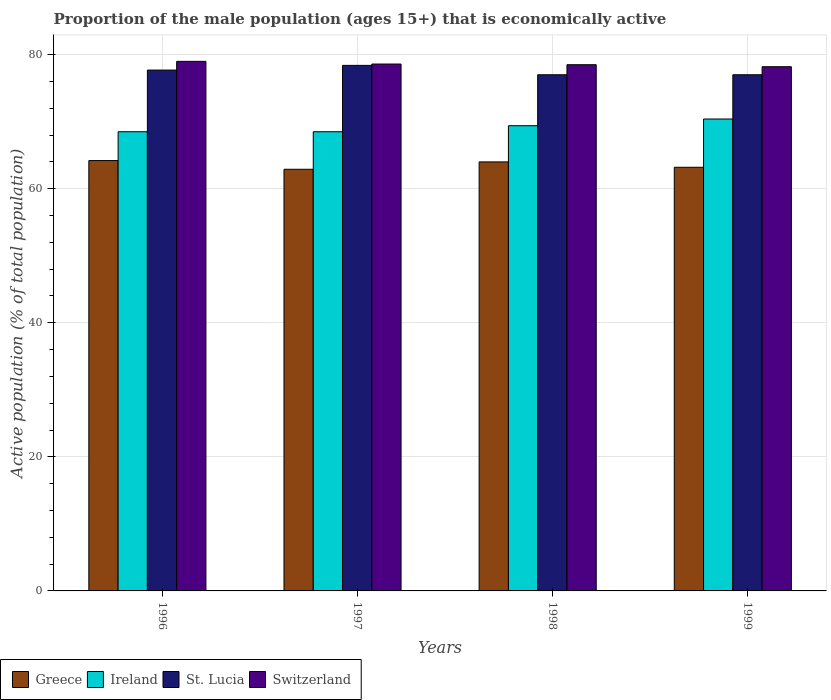How many different coloured bars are there?
Make the answer very short. 4. How many groups of bars are there?
Keep it short and to the point. 4. What is the label of the 1st group of bars from the left?
Your answer should be compact. 1996. In how many cases, is the number of bars for a given year not equal to the number of legend labels?
Offer a terse response. 0. What is the proportion of the male population that is economically active in Switzerland in 1997?
Your answer should be very brief. 78.6. Across all years, what is the maximum proportion of the male population that is economically active in Ireland?
Your answer should be compact. 70.4. Across all years, what is the minimum proportion of the male population that is economically active in Greece?
Ensure brevity in your answer.  62.9. In which year was the proportion of the male population that is economically active in Switzerland minimum?
Offer a very short reply. 1999. What is the total proportion of the male population that is economically active in Greece in the graph?
Offer a terse response. 254.3. What is the difference between the proportion of the male population that is economically active in Greece in 1996 and that in 1997?
Your response must be concise. 1.3. What is the difference between the proportion of the male population that is economically active in Greece in 1998 and the proportion of the male population that is economically active in Ireland in 1999?
Provide a short and direct response. -6.4. What is the average proportion of the male population that is economically active in Switzerland per year?
Your response must be concise. 78.57. In the year 1997, what is the difference between the proportion of the male population that is economically active in Switzerland and proportion of the male population that is economically active in Greece?
Offer a terse response. 15.7. In how many years, is the proportion of the male population that is economically active in Switzerland greater than 64 %?
Your answer should be compact. 4. What is the ratio of the proportion of the male population that is economically active in Greece in 1996 to that in 1998?
Ensure brevity in your answer.  1. Is the proportion of the male population that is economically active in St. Lucia in 1996 less than that in 1999?
Provide a short and direct response. No. Is the difference between the proportion of the male population that is economically active in Switzerland in 1996 and 1999 greater than the difference between the proportion of the male population that is economically active in Greece in 1996 and 1999?
Provide a short and direct response. No. What is the difference between the highest and the second highest proportion of the male population that is economically active in St. Lucia?
Ensure brevity in your answer.  0.7. What is the difference between the highest and the lowest proportion of the male population that is economically active in Greece?
Your answer should be compact. 1.3. What does the 2nd bar from the left in 1999 represents?
Provide a succinct answer. Ireland. What does the 4th bar from the right in 1998 represents?
Make the answer very short. Greece. Does the graph contain grids?
Your answer should be compact. Yes. How are the legend labels stacked?
Your answer should be compact. Horizontal. What is the title of the graph?
Make the answer very short. Proportion of the male population (ages 15+) that is economically active. What is the label or title of the X-axis?
Keep it short and to the point. Years. What is the label or title of the Y-axis?
Ensure brevity in your answer.  Active population (% of total population). What is the Active population (% of total population) of Greece in 1996?
Offer a very short reply. 64.2. What is the Active population (% of total population) in Ireland in 1996?
Provide a succinct answer. 68.5. What is the Active population (% of total population) of St. Lucia in 1996?
Provide a short and direct response. 77.7. What is the Active population (% of total population) in Switzerland in 1996?
Ensure brevity in your answer.  79. What is the Active population (% of total population) in Greece in 1997?
Offer a terse response. 62.9. What is the Active population (% of total population) in Ireland in 1997?
Your answer should be compact. 68.5. What is the Active population (% of total population) in St. Lucia in 1997?
Offer a terse response. 78.4. What is the Active population (% of total population) in Switzerland in 1997?
Your answer should be very brief. 78.6. What is the Active population (% of total population) in Ireland in 1998?
Provide a succinct answer. 69.4. What is the Active population (% of total population) of Switzerland in 1998?
Offer a terse response. 78.5. What is the Active population (% of total population) in Greece in 1999?
Offer a terse response. 63.2. What is the Active population (% of total population) of Ireland in 1999?
Make the answer very short. 70.4. What is the Active population (% of total population) in St. Lucia in 1999?
Give a very brief answer. 77. What is the Active population (% of total population) in Switzerland in 1999?
Provide a succinct answer. 78.2. Across all years, what is the maximum Active population (% of total population) in Greece?
Make the answer very short. 64.2. Across all years, what is the maximum Active population (% of total population) in Ireland?
Offer a terse response. 70.4. Across all years, what is the maximum Active population (% of total population) in St. Lucia?
Offer a very short reply. 78.4. Across all years, what is the maximum Active population (% of total population) of Switzerland?
Keep it short and to the point. 79. Across all years, what is the minimum Active population (% of total population) in Greece?
Keep it short and to the point. 62.9. Across all years, what is the minimum Active population (% of total population) in Ireland?
Your response must be concise. 68.5. Across all years, what is the minimum Active population (% of total population) in Switzerland?
Keep it short and to the point. 78.2. What is the total Active population (% of total population) of Greece in the graph?
Offer a very short reply. 254.3. What is the total Active population (% of total population) in Ireland in the graph?
Your response must be concise. 276.8. What is the total Active population (% of total population) in St. Lucia in the graph?
Make the answer very short. 310.1. What is the total Active population (% of total population) of Switzerland in the graph?
Provide a succinct answer. 314.3. What is the difference between the Active population (% of total population) of Ireland in 1996 and that in 1997?
Ensure brevity in your answer.  0. What is the difference between the Active population (% of total population) of St. Lucia in 1996 and that in 1997?
Offer a very short reply. -0.7. What is the difference between the Active population (% of total population) of Switzerland in 1996 and that in 1997?
Offer a terse response. 0.4. What is the difference between the Active population (% of total population) in Ireland in 1996 and that in 1998?
Offer a terse response. -0.9. What is the difference between the Active population (% of total population) in Ireland in 1996 and that in 1999?
Your answer should be very brief. -1.9. What is the difference between the Active population (% of total population) in Switzerland in 1996 and that in 1999?
Offer a terse response. 0.8. What is the difference between the Active population (% of total population) in Greece in 1997 and that in 1998?
Offer a terse response. -1.1. What is the difference between the Active population (% of total population) in Switzerland in 1997 and that in 1998?
Ensure brevity in your answer.  0.1. What is the difference between the Active population (% of total population) of St. Lucia in 1997 and that in 1999?
Provide a short and direct response. 1.4. What is the difference between the Active population (% of total population) in Switzerland in 1997 and that in 1999?
Provide a short and direct response. 0.4. What is the difference between the Active population (% of total population) in Greece in 1998 and that in 1999?
Give a very brief answer. 0.8. What is the difference between the Active population (% of total population) in Ireland in 1998 and that in 1999?
Make the answer very short. -1. What is the difference between the Active population (% of total population) in St. Lucia in 1998 and that in 1999?
Offer a terse response. 0. What is the difference between the Active population (% of total population) of Greece in 1996 and the Active population (% of total population) of Ireland in 1997?
Ensure brevity in your answer.  -4.3. What is the difference between the Active population (% of total population) of Greece in 1996 and the Active population (% of total population) of St. Lucia in 1997?
Offer a terse response. -14.2. What is the difference between the Active population (% of total population) in Greece in 1996 and the Active population (% of total population) in Switzerland in 1997?
Make the answer very short. -14.4. What is the difference between the Active population (% of total population) in Ireland in 1996 and the Active population (% of total population) in Switzerland in 1997?
Offer a terse response. -10.1. What is the difference between the Active population (% of total population) in St. Lucia in 1996 and the Active population (% of total population) in Switzerland in 1997?
Provide a succinct answer. -0.9. What is the difference between the Active population (% of total population) of Greece in 1996 and the Active population (% of total population) of Switzerland in 1998?
Offer a terse response. -14.3. What is the difference between the Active population (% of total population) of Ireland in 1996 and the Active population (% of total population) of St. Lucia in 1998?
Give a very brief answer. -8.5. What is the difference between the Active population (% of total population) of Ireland in 1996 and the Active population (% of total population) of Switzerland in 1998?
Ensure brevity in your answer.  -10. What is the difference between the Active population (% of total population) in Greece in 1996 and the Active population (% of total population) in Ireland in 1999?
Your answer should be very brief. -6.2. What is the difference between the Active population (% of total population) in Ireland in 1996 and the Active population (% of total population) in Switzerland in 1999?
Ensure brevity in your answer.  -9.7. What is the difference between the Active population (% of total population) in Greece in 1997 and the Active population (% of total population) in Ireland in 1998?
Your answer should be very brief. -6.5. What is the difference between the Active population (% of total population) of Greece in 1997 and the Active population (% of total population) of St. Lucia in 1998?
Offer a terse response. -14.1. What is the difference between the Active population (% of total population) of Greece in 1997 and the Active population (% of total population) of Switzerland in 1998?
Offer a terse response. -15.6. What is the difference between the Active population (% of total population) of Ireland in 1997 and the Active population (% of total population) of St. Lucia in 1998?
Keep it short and to the point. -8.5. What is the difference between the Active population (% of total population) in Ireland in 1997 and the Active population (% of total population) in Switzerland in 1998?
Keep it short and to the point. -10. What is the difference between the Active population (% of total population) in Greece in 1997 and the Active population (% of total population) in Ireland in 1999?
Your answer should be compact. -7.5. What is the difference between the Active population (% of total population) in Greece in 1997 and the Active population (% of total population) in St. Lucia in 1999?
Your answer should be compact. -14.1. What is the difference between the Active population (% of total population) in Greece in 1997 and the Active population (% of total population) in Switzerland in 1999?
Offer a very short reply. -15.3. What is the difference between the Active population (% of total population) of Ireland in 1997 and the Active population (% of total population) of St. Lucia in 1999?
Offer a very short reply. -8.5. What is the difference between the Active population (% of total population) in Greece in 1998 and the Active population (% of total population) in St. Lucia in 1999?
Make the answer very short. -13. What is the average Active population (% of total population) in Greece per year?
Make the answer very short. 63.58. What is the average Active population (% of total population) in Ireland per year?
Give a very brief answer. 69.2. What is the average Active population (% of total population) in St. Lucia per year?
Provide a succinct answer. 77.53. What is the average Active population (% of total population) of Switzerland per year?
Give a very brief answer. 78.58. In the year 1996, what is the difference between the Active population (% of total population) of Greece and Active population (% of total population) of St. Lucia?
Provide a succinct answer. -13.5. In the year 1996, what is the difference between the Active population (% of total population) of Greece and Active population (% of total population) of Switzerland?
Ensure brevity in your answer.  -14.8. In the year 1996, what is the difference between the Active population (% of total population) in St. Lucia and Active population (% of total population) in Switzerland?
Ensure brevity in your answer.  -1.3. In the year 1997, what is the difference between the Active population (% of total population) in Greece and Active population (% of total population) in St. Lucia?
Offer a terse response. -15.5. In the year 1997, what is the difference between the Active population (% of total population) of Greece and Active population (% of total population) of Switzerland?
Your answer should be compact. -15.7. In the year 1997, what is the difference between the Active population (% of total population) of Ireland and Active population (% of total population) of St. Lucia?
Offer a terse response. -9.9. In the year 1997, what is the difference between the Active population (% of total population) in St. Lucia and Active population (% of total population) in Switzerland?
Offer a terse response. -0.2. In the year 1998, what is the difference between the Active population (% of total population) in Greece and Active population (% of total population) in Ireland?
Offer a terse response. -5.4. In the year 1998, what is the difference between the Active population (% of total population) of Greece and Active population (% of total population) of St. Lucia?
Your answer should be compact. -13. In the year 1998, what is the difference between the Active population (% of total population) in Greece and Active population (% of total population) in Switzerland?
Give a very brief answer. -14.5. In the year 1998, what is the difference between the Active population (% of total population) in Ireland and Active population (% of total population) in St. Lucia?
Offer a terse response. -7.6. In the year 1998, what is the difference between the Active population (% of total population) in Ireland and Active population (% of total population) in Switzerland?
Offer a terse response. -9.1. In the year 1998, what is the difference between the Active population (% of total population) in St. Lucia and Active population (% of total population) in Switzerland?
Make the answer very short. -1.5. In the year 1999, what is the difference between the Active population (% of total population) of Greece and Active population (% of total population) of Ireland?
Provide a succinct answer. -7.2. In the year 1999, what is the difference between the Active population (% of total population) of Greece and Active population (% of total population) of St. Lucia?
Your response must be concise. -13.8. In the year 1999, what is the difference between the Active population (% of total population) of Ireland and Active population (% of total population) of St. Lucia?
Your response must be concise. -6.6. In the year 1999, what is the difference between the Active population (% of total population) of Ireland and Active population (% of total population) of Switzerland?
Ensure brevity in your answer.  -7.8. What is the ratio of the Active population (% of total population) in Greece in 1996 to that in 1997?
Your response must be concise. 1.02. What is the ratio of the Active population (% of total population) of Ireland in 1996 to that in 1997?
Offer a terse response. 1. What is the ratio of the Active population (% of total population) in St. Lucia in 1996 to that in 1997?
Your response must be concise. 0.99. What is the ratio of the Active population (% of total population) of Switzerland in 1996 to that in 1997?
Keep it short and to the point. 1.01. What is the ratio of the Active population (% of total population) of St. Lucia in 1996 to that in 1998?
Make the answer very short. 1.01. What is the ratio of the Active population (% of total population) in Switzerland in 1996 to that in 1998?
Offer a very short reply. 1.01. What is the ratio of the Active population (% of total population) in Greece in 1996 to that in 1999?
Ensure brevity in your answer.  1.02. What is the ratio of the Active population (% of total population) in St. Lucia in 1996 to that in 1999?
Make the answer very short. 1.01. What is the ratio of the Active population (% of total population) of Switzerland in 1996 to that in 1999?
Offer a terse response. 1.01. What is the ratio of the Active population (% of total population) in Greece in 1997 to that in 1998?
Give a very brief answer. 0.98. What is the ratio of the Active population (% of total population) of St. Lucia in 1997 to that in 1998?
Provide a short and direct response. 1.02. What is the ratio of the Active population (% of total population) of Switzerland in 1997 to that in 1998?
Keep it short and to the point. 1. What is the ratio of the Active population (% of total population) in Greece in 1997 to that in 1999?
Offer a very short reply. 1. What is the ratio of the Active population (% of total population) of St. Lucia in 1997 to that in 1999?
Your response must be concise. 1.02. What is the ratio of the Active population (% of total population) of Switzerland in 1997 to that in 1999?
Your answer should be compact. 1.01. What is the ratio of the Active population (% of total population) in Greece in 1998 to that in 1999?
Offer a very short reply. 1.01. What is the ratio of the Active population (% of total population) in Ireland in 1998 to that in 1999?
Make the answer very short. 0.99. What is the difference between the highest and the second highest Active population (% of total population) of Greece?
Keep it short and to the point. 0.2. What is the difference between the highest and the second highest Active population (% of total population) in Ireland?
Provide a succinct answer. 1. What is the difference between the highest and the second highest Active population (% of total population) in Switzerland?
Keep it short and to the point. 0.4. What is the difference between the highest and the lowest Active population (% of total population) of St. Lucia?
Provide a succinct answer. 1.4. 